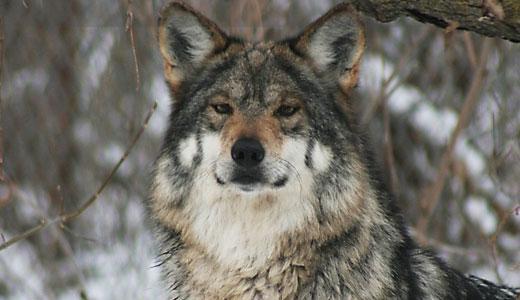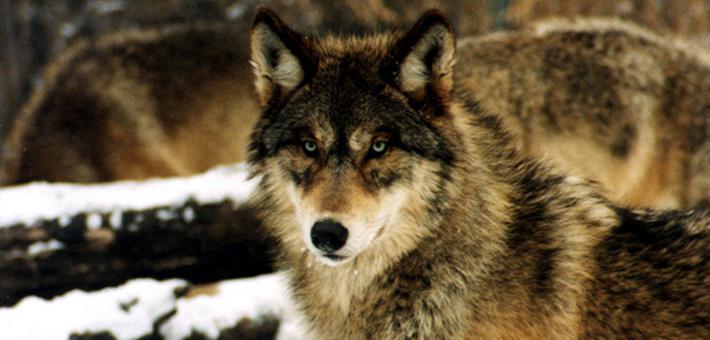The first image is the image on the left, the second image is the image on the right. Analyze the images presented: Is the assertion "One wolf is facing to the right." valid? Answer yes or no. No. 